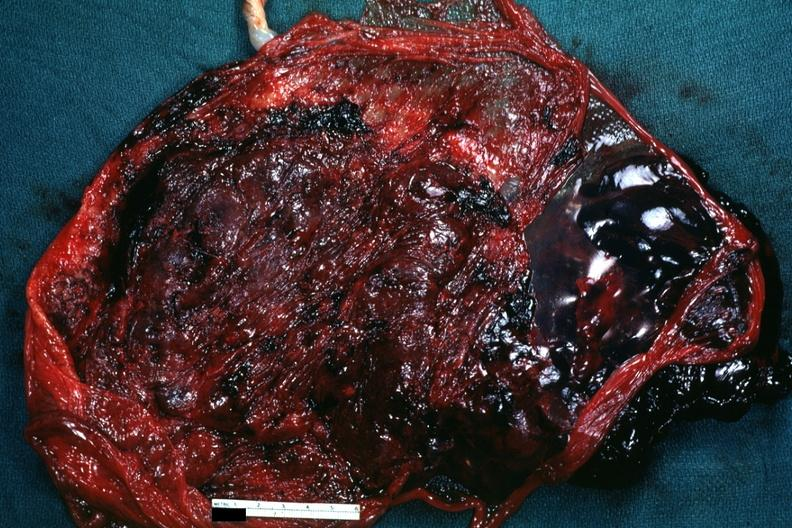s female reproductive present?
Answer the question using a single word or phrase. No 